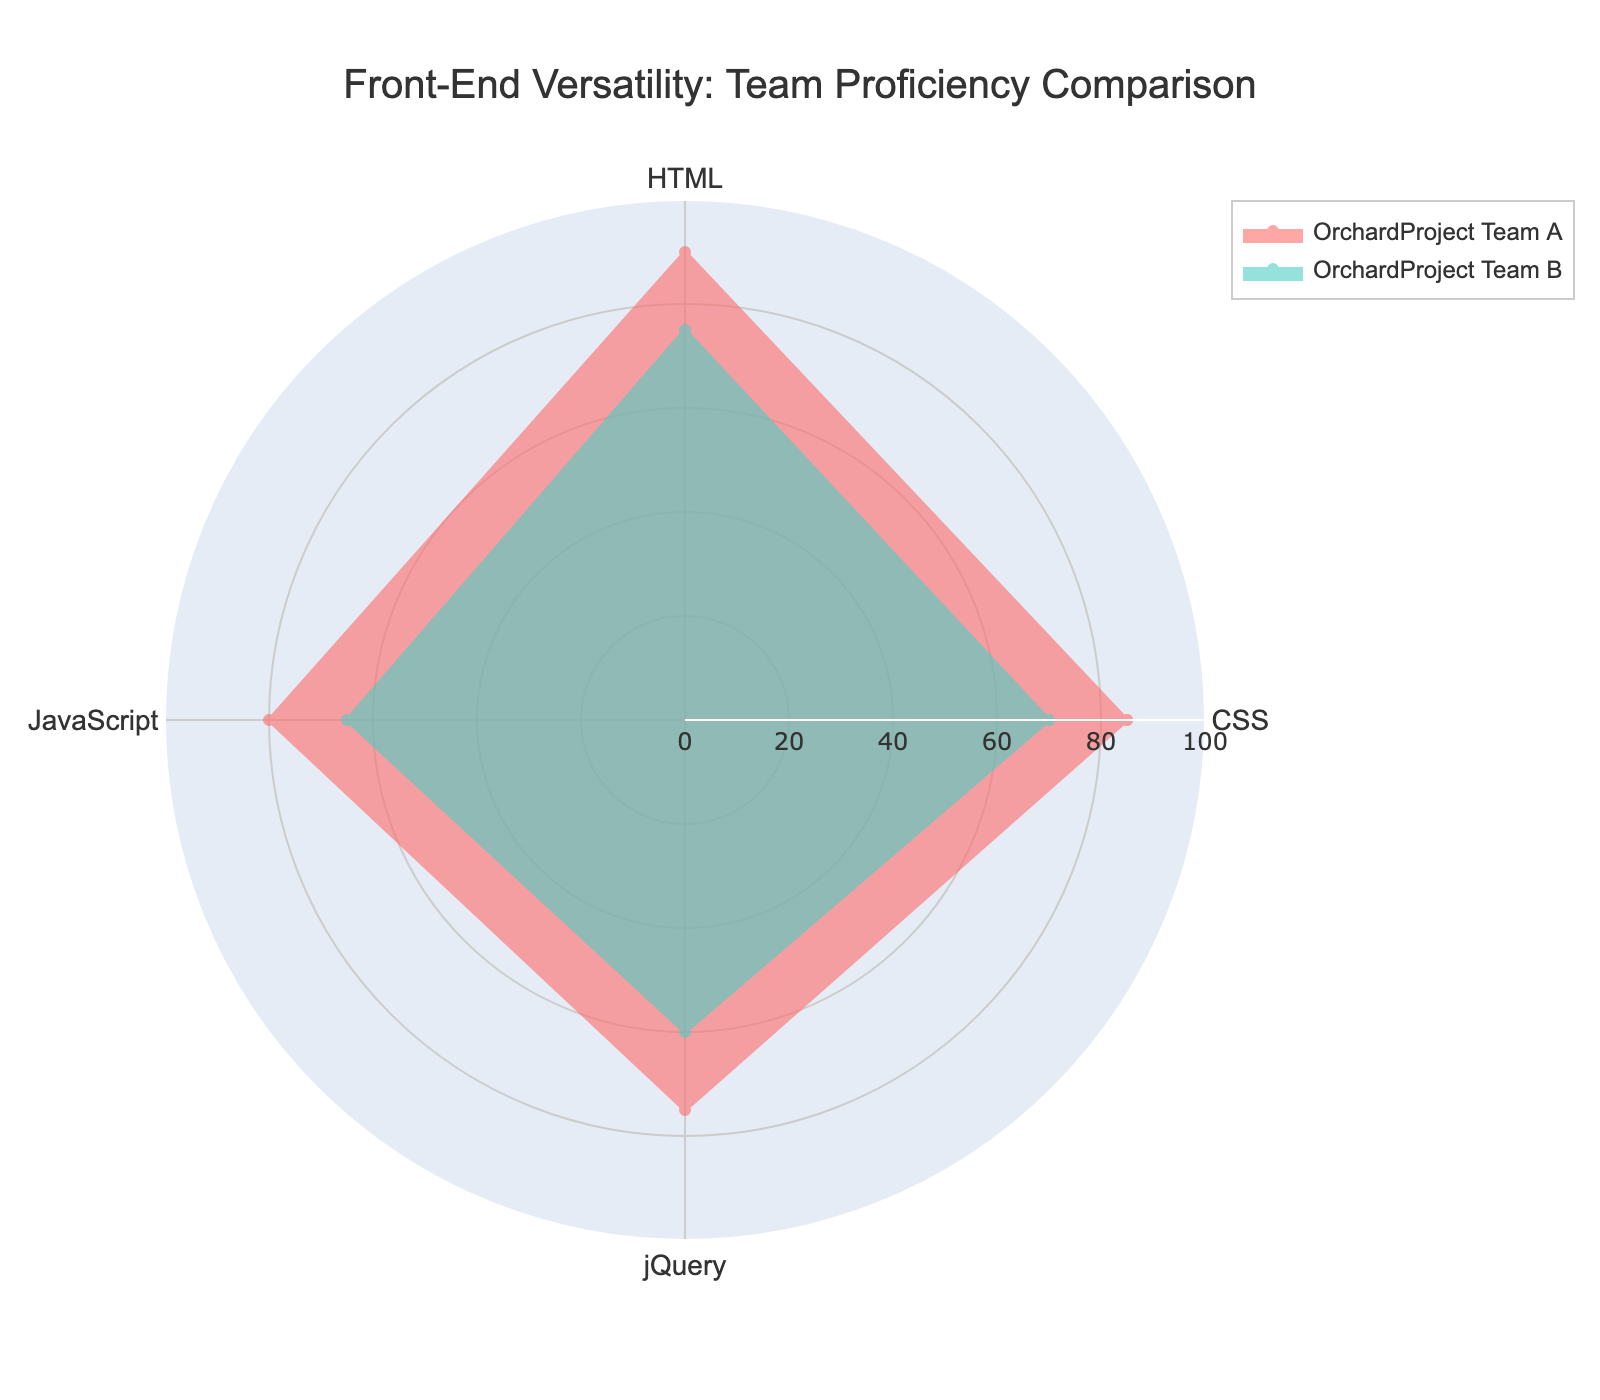What's the title of the figure? The title of the figure is positioned at the top center and it summarizes the main focus. Here, the title is "Front-End Versatility: Team Proficiency Comparison".
Answer: Front-End Versatility: Team Proficiency Comparison What are the four skills shown in the radar chart? The radar chart has four distinct axes labeled with the skills represented. These axes are labeled CSS, HTML, JavaScript, and jQuery.
Answer: CSS, HTML, JavaScript, jQuery Which team has the highest proficiency in HTML? By looking at the radar chart, the team with the highest point on the HTML axis demonstrates the highest proficiency. Team A has a proficiency level of 90 while Team B has 75 in HTML, so Team A has the highest proficiency.
Answer: OrchardProject Team A What is the overall trend in proficiency levels between OrchardProject Team A and Team B? The overall trend can be determined by comparing the filled areas of the polygons. OrchardProject Team A generally shows higher proficiency levels across all skills (CSS, HTML, JavaScript, jQuery) compared to Team B.
Answer: OrchardProject Team A generally shows higher proficiency What's the difference in proficiency levels between the two teams for JavaScript? To find the difference, subtract the proficiency level of Team B from Team A in JavaScript. This is calculated as 80 (Team A) - 65 (Team B) = 15.
Answer: 15 Which skill shows the smallest proficiency gap between the two teams? By comparing the differences in proficiency levels for each skill, the smallest gap can be identified. The gaps are: CSS (15), HTML (15), JavaScript (15), and jQuery (15). The gap is the same for all skills in this case.
Answer: jQuery (or any skill, as the gap is 15 for all) How does the proficiency of Team B in jQuery compare to their proficiency in CSS? Compare the points on the radar chart for Team B for both skills. Team B has a proficiency of 60 in jQuery and 70 in CSS. Team B is less proficient in jQuery by 10 points.
Answer: Less proficient by 10 points Which team has better overall proficiency in front-end skills? Overall proficiency can be judged by comparing the combined filled areas in the radar chart. Team A generally has higher values across all four skills, indicating better overall proficiency.
Answer: OrchardProject Team A If you combine the proficiency percentages of all four skills, which team has a higher total? Sum the proficiency levels for each team: Team A (85 + 90 + 80 + 75) = 330, Team B (70 + 75 + 65 + 60) = 270. Team A has a higher total.
Answer: OrchardProject Team A What is the average proficiency level in CSS across both teams? The average can be calculated by adding the proficiency levels in CSS for both teams and dividing by the number of teams: (85 + 70)/2 = 77.5.
Answer: 77.5 